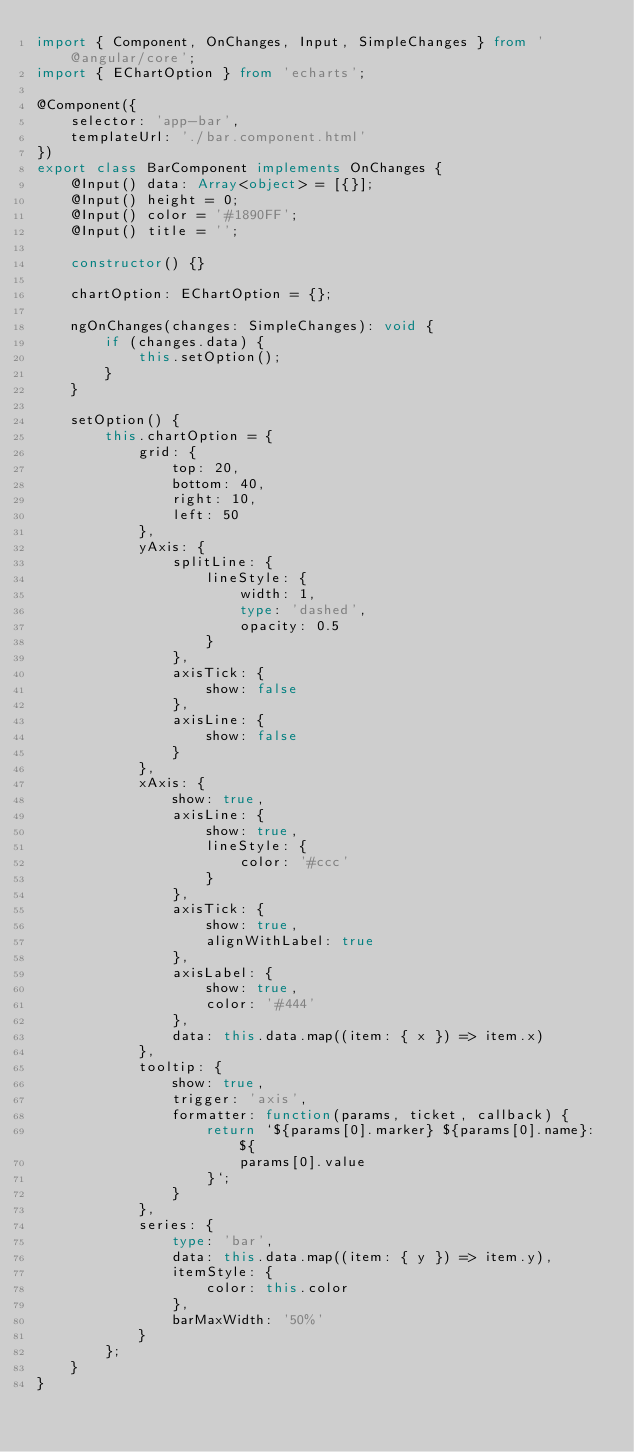Convert code to text. <code><loc_0><loc_0><loc_500><loc_500><_TypeScript_>import { Component, OnChanges, Input, SimpleChanges } from '@angular/core';
import { EChartOption } from 'echarts';

@Component({
    selector: 'app-bar',
    templateUrl: './bar.component.html'
})
export class BarComponent implements OnChanges {
    @Input() data: Array<object> = [{}];
    @Input() height = 0;
    @Input() color = '#1890FF';
    @Input() title = '';

    constructor() {}

    chartOption: EChartOption = {};

    ngOnChanges(changes: SimpleChanges): void {
        if (changes.data) {
            this.setOption();
        }
    }

    setOption() {
        this.chartOption = {
            grid: {
                top: 20,
                bottom: 40,
                right: 10,
                left: 50
            },
            yAxis: {
                splitLine: {
                    lineStyle: {
                        width: 1,
                        type: 'dashed',
                        opacity: 0.5
                    }
                },
                axisTick: {
                    show: false
                },
                axisLine: {
                    show: false
                }
            },
            xAxis: {
                show: true,
                axisLine: {
                    show: true,
                    lineStyle: {
                        color: '#ccc'
                    }
                },
                axisTick: {
                    show: true,
                    alignWithLabel: true
                },
                axisLabel: {
                    show: true,
                    color: '#444'
                },
                data: this.data.map((item: { x }) => item.x)
            },
            tooltip: {
                show: true,
                trigger: 'axis',
                formatter: function(params, ticket, callback) {
                    return `${params[0].marker} ${params[0].name}: ${
                        params[0].value
                    }`;
                }
            },
            series: {
                type: 'bar',
                data: this.data.map((item: { y }) => item.y),
                itemStyle: {
                    color: this.color
                },
                barMaxWidth: '50%'
            }
        };
    }
}
</code> 